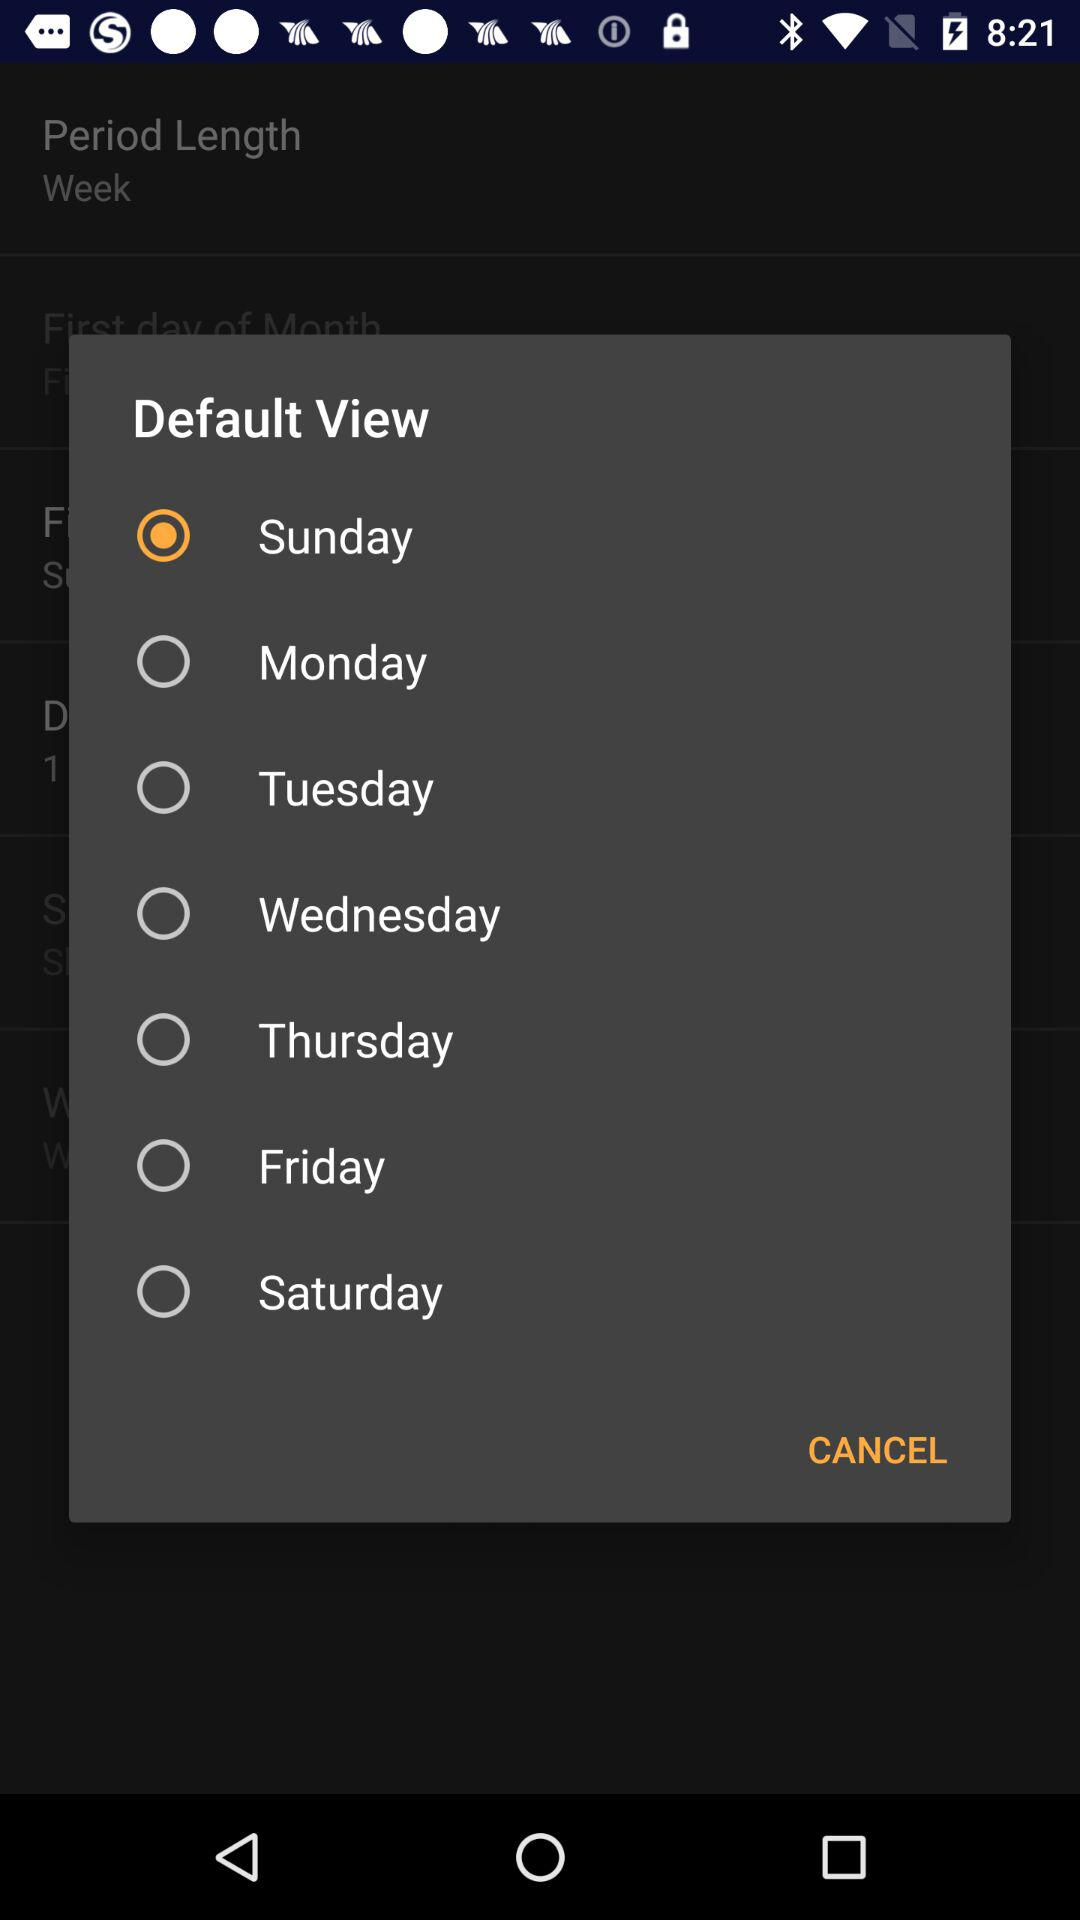Which day is selected? The selected day is "Sunday". 